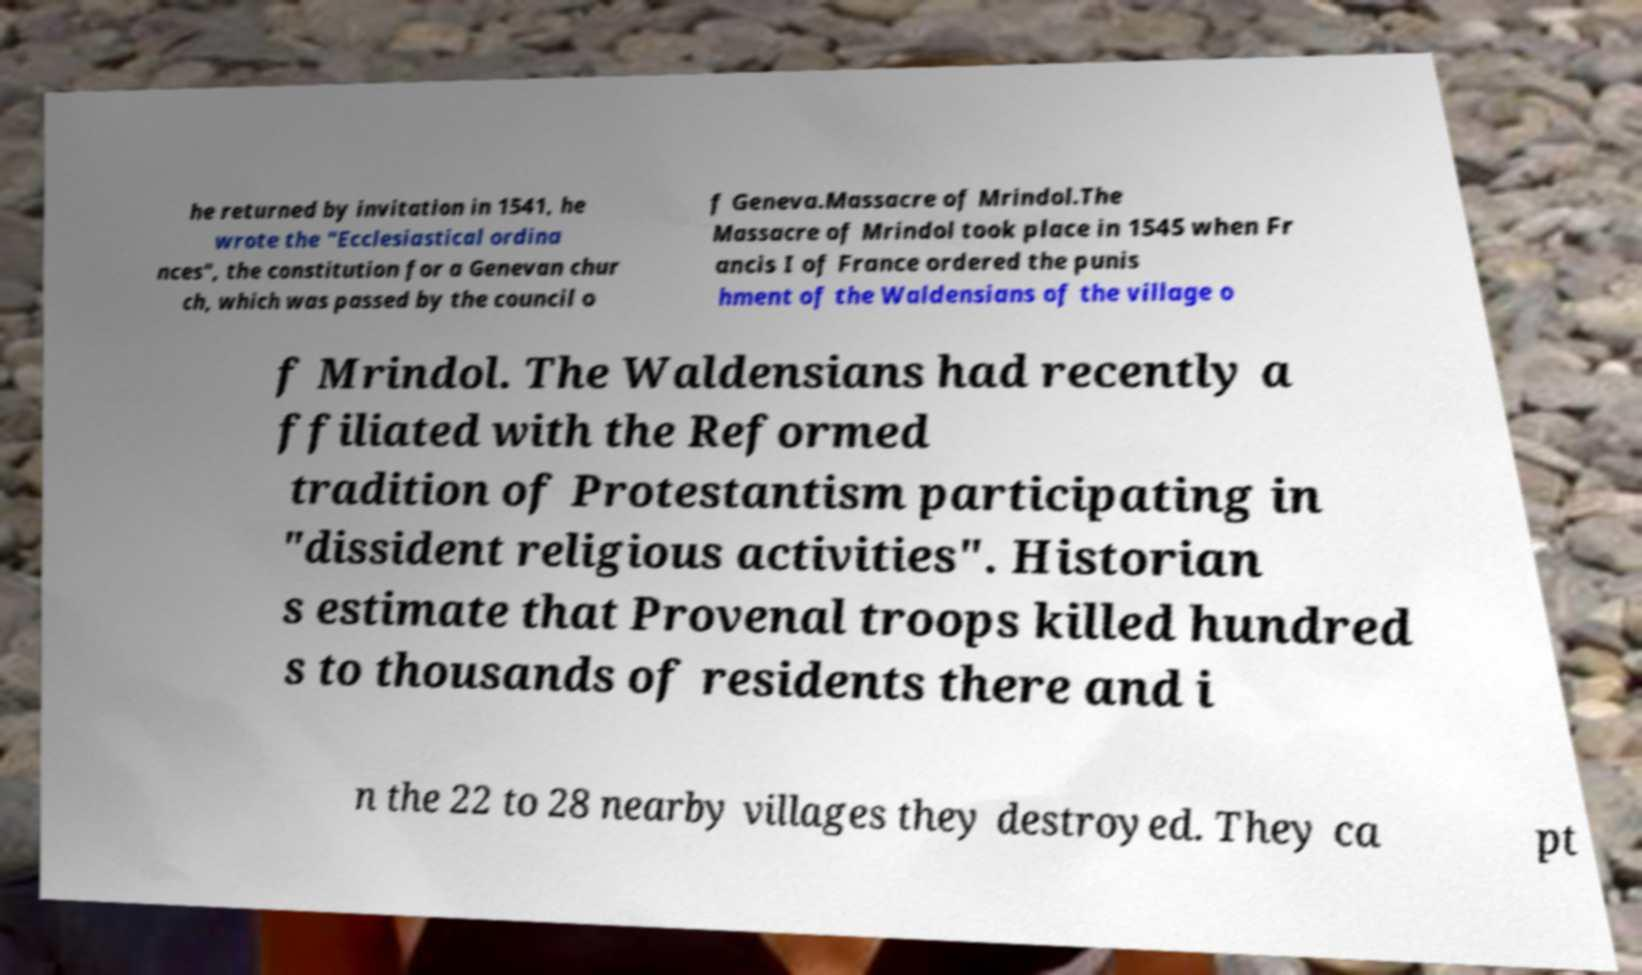Can you accurately transcribe the text from the provided image for me? he returned by invitation in 1541, he wrote the "Ecclesiastical ordina nces", the constitution for a Genevan chur ch, which was passed by the council o f Geneva.Massacre of Mrindol.The Massacre of Mrindol took place in 1545 when Fr ancis I of France ordered the punis hment of the Waldensians of the village o f Mrindol. The Waldensians had recently a ffiliated with the Reformed tradition of Protestantism participating in "dissident religious activities". Historian s estimate that Provenal troops killed hundred s to thousands of residents there and i n the 22 to 28 nearby villages they destroyed. They ca pt 